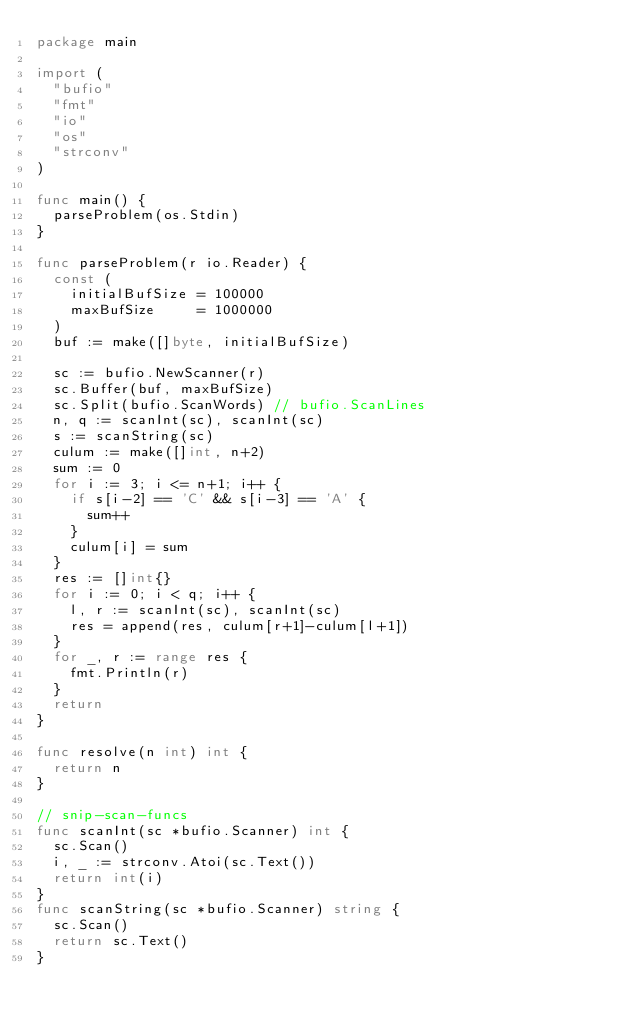Convert code to text. <code><loc_0><loc_0><loc_500><loc_500><_Go_>package main

import (
	"bufio"
	"fmt"
	"io"
	"os"
	"strconv"
)

func main() {
	parseProblem(os.Stdin)
}

func parseProblem(r io.Reader) {
	const (
		initialBufSize = 100000
		maxBufSize     = 1000000
	)
	buf := make([]byte, initialBufSize)

	sc := bufio.NewScanner(r)
	sc.Buffer(buf, maxBufSize)
	sc.Split(bufio.ScanWords) // bufio.ScanLines
	n, q := scanInt(sc), scanInt(sc)
	s := scanString(sc)
	culum := make([]int, n+2)
	sum := 0
	for i := 3; i <= n+1; i++ {
		if s[i-2] == 'C' && s[i-3] == 'A' {
			sum++
		}
		culum[i] = sum
	}
	res := []int{}
	for i := 0; i < q; i++ {
		l, r := scanInt(sc), scanInt(sc)
		res = append(res, culum[r+1]-culum[l+1])
	}
	for _, r := range res {
		fmt.Println(r)
	}
	return
}

func resolve(n int) int {
	return n
}

// snip-scan-funcs
func scanInt(sc *bufio.Scanner) int {
	sc.Scan()
	i, _ := strconv.Atoi(sc.Text())
	return int(i)
}
func scanString(sc *bufio.Scanner) string {
	sc.Scan()
	return sc.Text()
}
</code> 